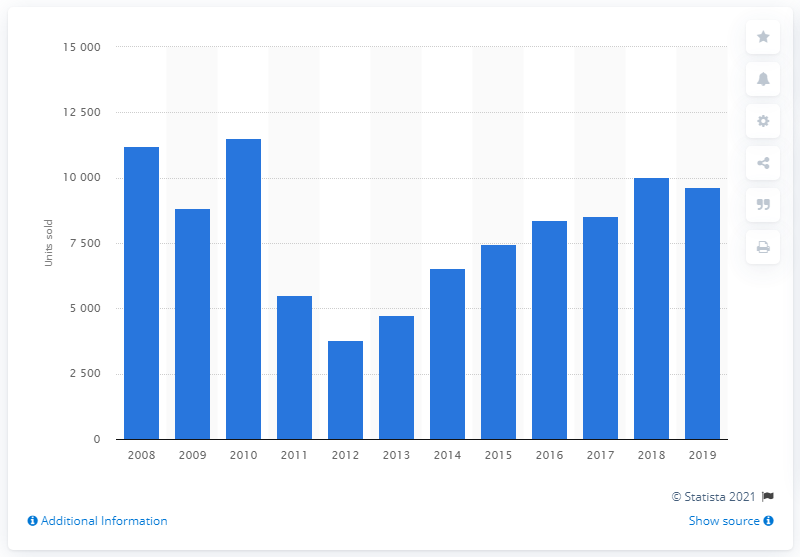Outline some significant characteristics in this image. In 2012, Toyota's annual sales in Portugal were 3,791 units, which was the lowest sales figure recorded that year. In the period between 2013 and 2018, a total of 3,791 cars were sold in Portugal. In 2019, Toyota sold a total of 9,645 vehicles in Portugal. In the year 2011, Toyota's sales dropped by half. The highest number of cars sold in Portugal between 2008 and 2019 was 11,499. 